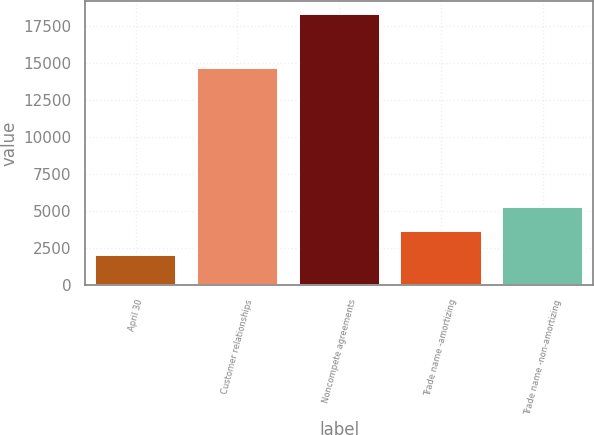<chart> <loc_0><loc_0><loc_500><loc_500><bar_chart><fcel>April 30<fcel>Customer relationships<fcel>Noncompete agreements<fcel>Trade name -amortizing<fcel>Trade name -non-amortizing<nl><fcel>2007<fcel>14654<fcel>18279<fcel>3634.2<fcel>5261.4<nl></chart> 